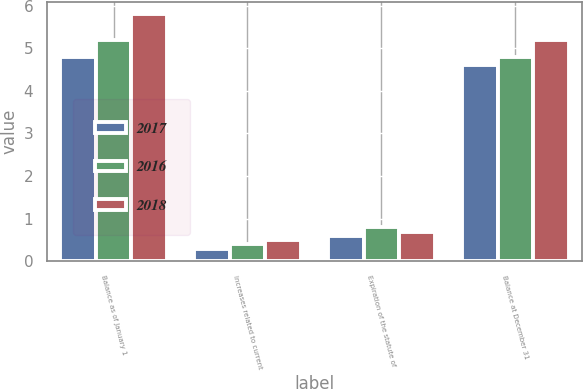Convert chart. <chart><loc_0><loc_0><loc_500><loc_500><stacked_bar_chart><ecel><fcel>Balance as of January 1<fcel>Increases related to current<fcel>Expiration of the statute of<fcel>Balance at December 31<nl><fcel>2017<fcel>4.8<fcel>0.3<fcel>0.6<fcel>4.6<nl><fcel>2016<fcel>5.2<fcel>0.4<fcel>0.8<fcel>4.8<nl><fcel>2018<fcel>5.8<fcel>0.5<fcel>0.7<fcel>5.2<nl></chart> 